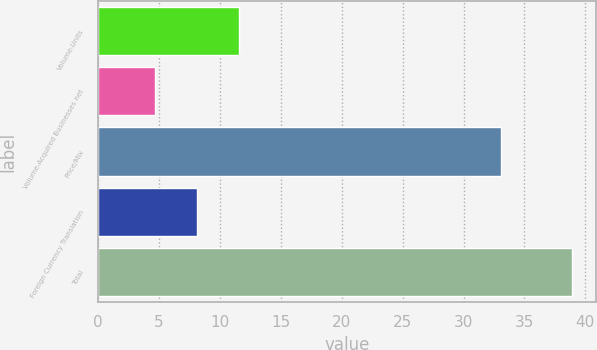<chart> <loc_0><loc_0><loc_500><loc_500><bar_chart><fcel>Volume-Units<fcel>Volume-Acquired Businesses net<fcel>Price/Mix<fcel>Foreign Currency Translation<fcel>Total<nl><fcel>11.54<fcel>4.7<fcel>33.1<fcel>8.12<fcel>38.9<nl></chart> 